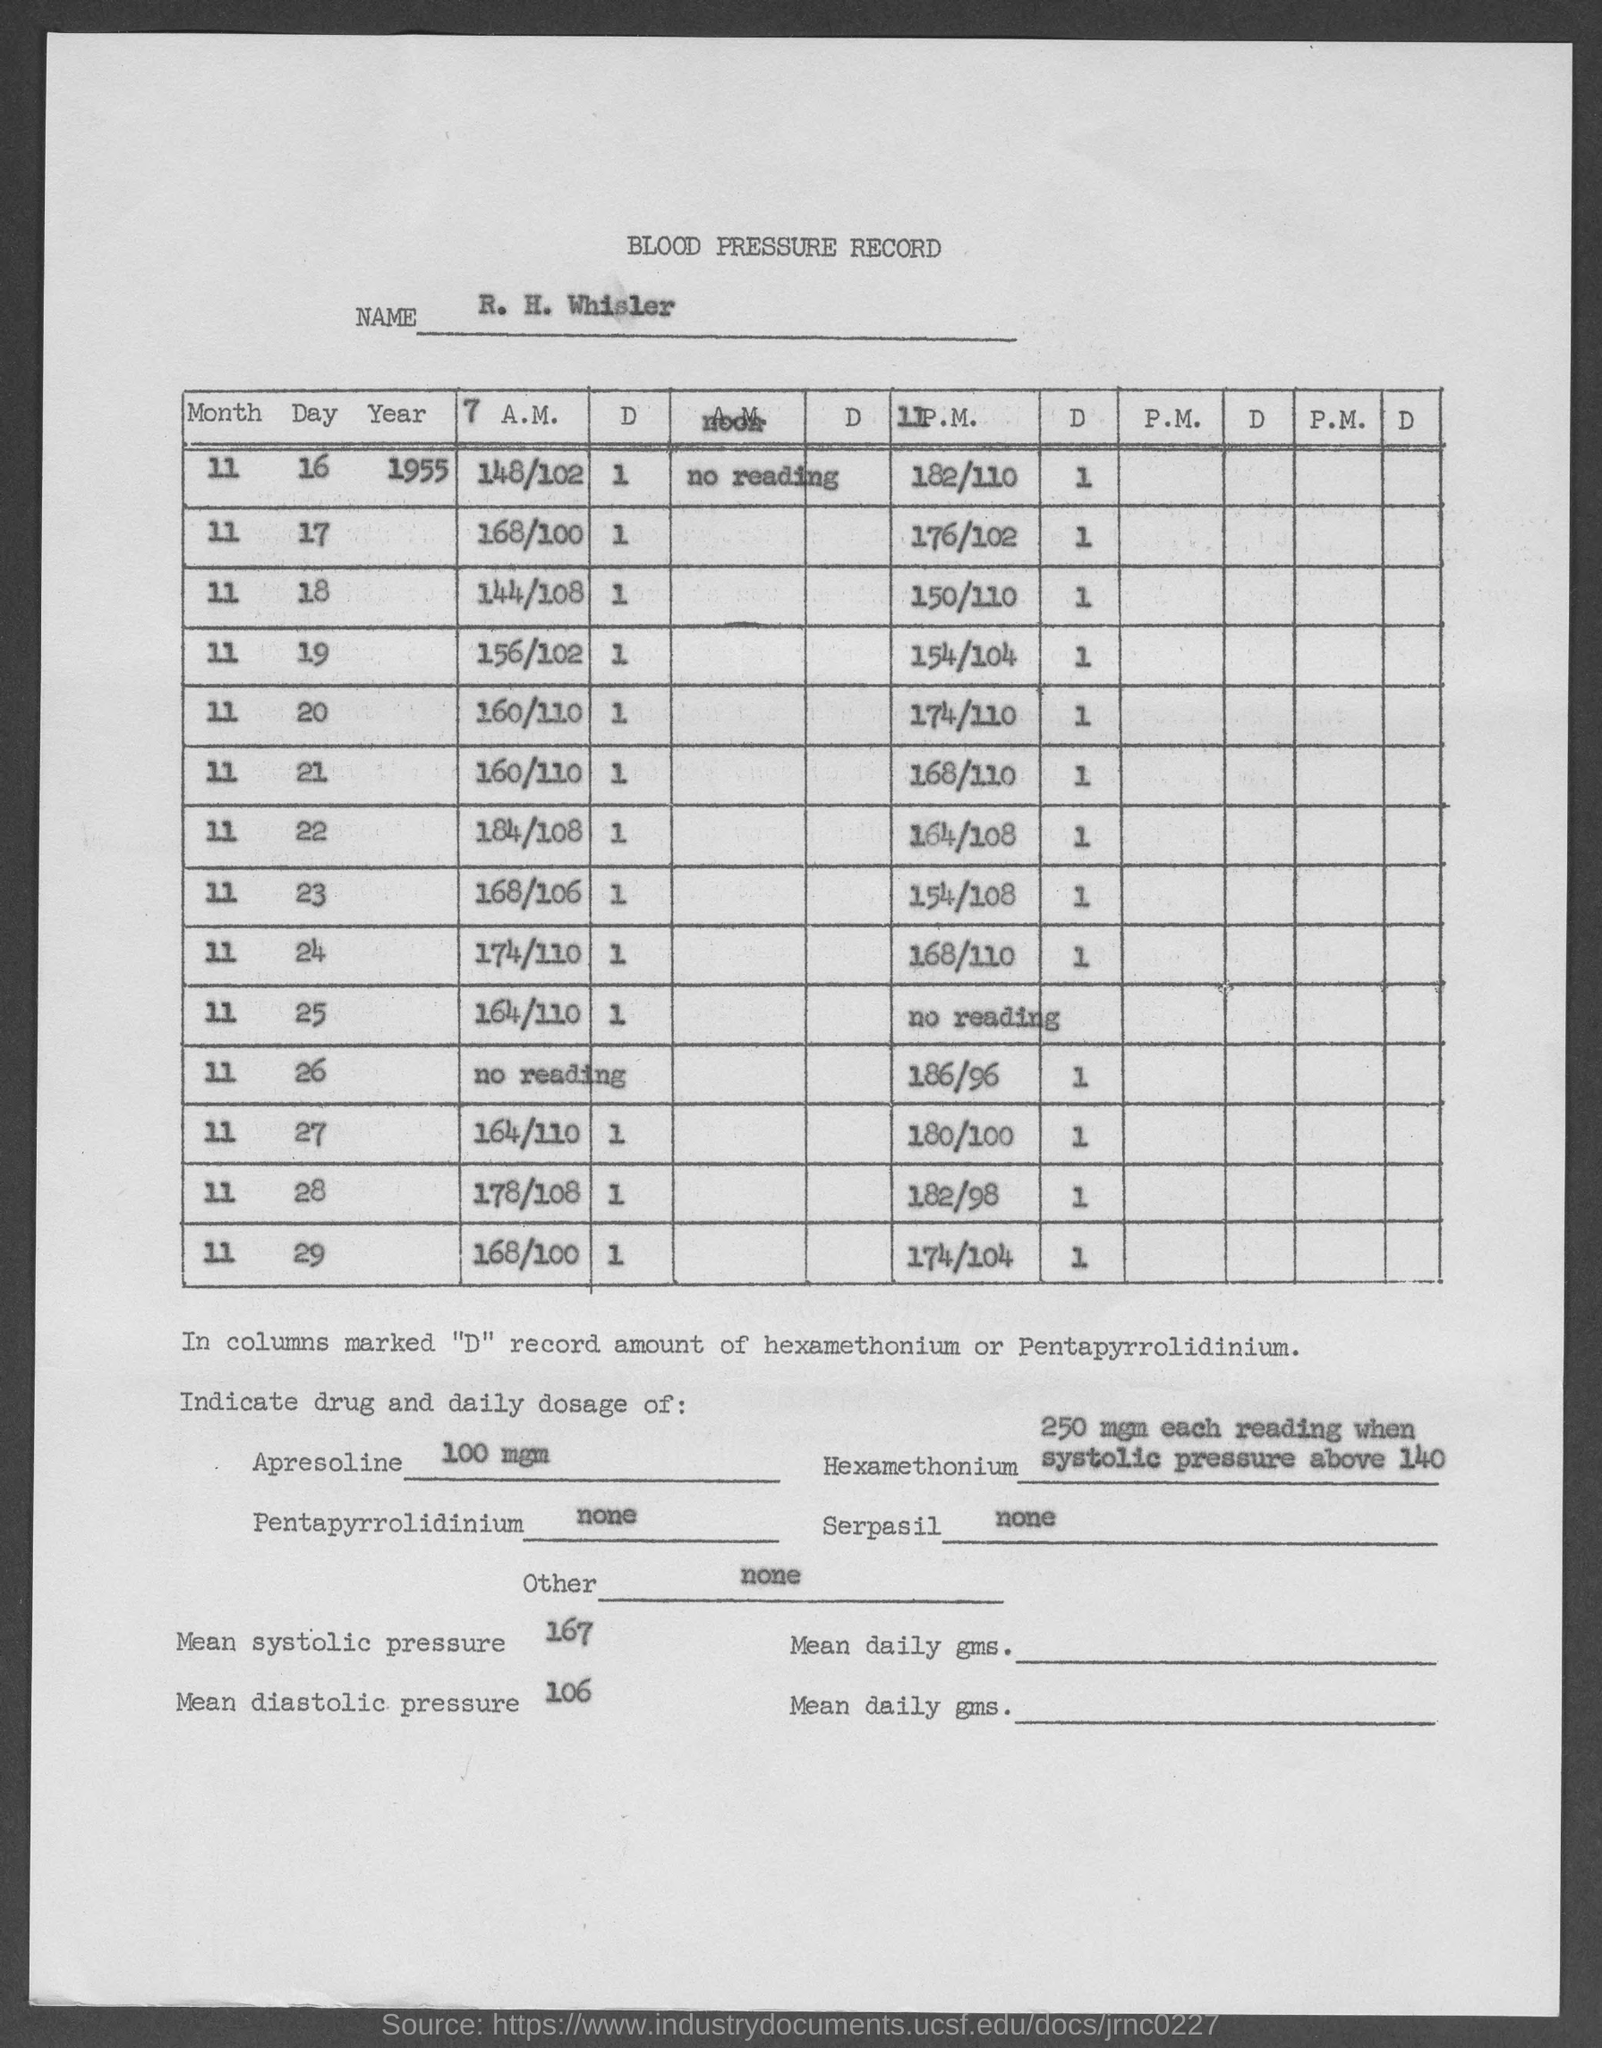Identify some key points in this picture. There is no daily dosage for Other as it is not included in the table. The mean systolic pressure is 167. The recommended daily dose of Apresoline is 100 mg. Pentapyrrolidinium does not have a daily dosage. There is no daily dosage recommended for Serpasil. 